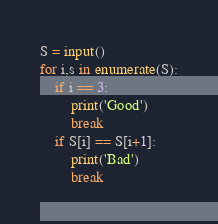<code> <loc_0><loc_0><loc_500><loc_500><_Python_>S = input()
for i,s in enumerate(S):
    if i == 3:
        print('Good')
        break
    if S[i] == S[i+1]:
        print('Bad')
        break</code> 